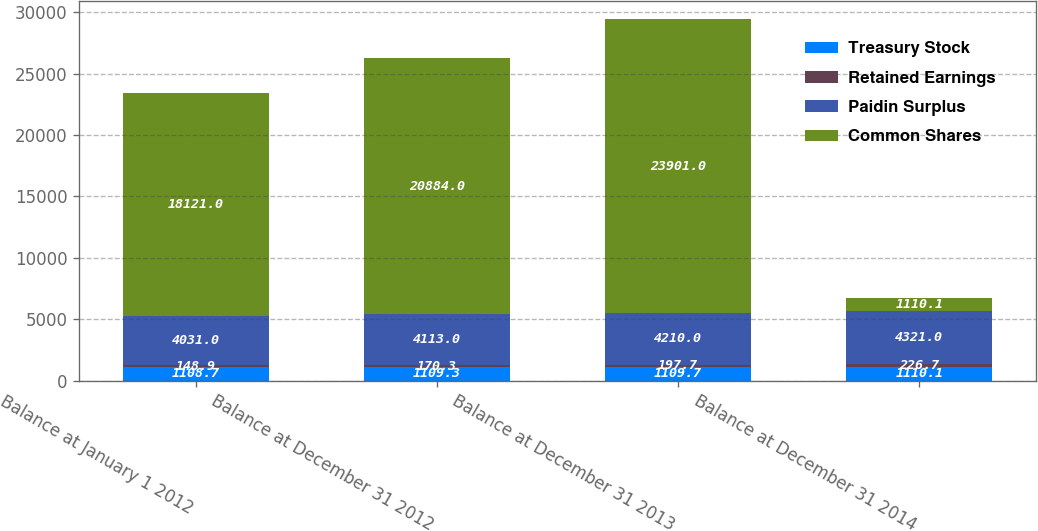Convert chart to OTSL. <chart><loc_0><loc_0><loc_500><loc_500><stacked_bar_chart><ecel><fcel>Balance at January 1 2012<fcel>Balance at December 31 2012<fcel>Balance at December 31 2013<fcel>Balance at December 31 2014<nl><fcel>Treasury Stock<fcel>1108.7<fcel>1109.3<fcel>1109.7<fcel>1110.1<nl><fcel>Retained Earnings<fcel>148.9<fcel>170.3<fcel>197.7<fcel>226.7<nl><fcel>Paidin Surplus<fcel>4031<fcel>4113<fcel>4210<fcel>4321<nl><fcel>Common Shares<fcel>18121<fcel>20884<fcel>23901<fcel>1110.1<nl></chart> 